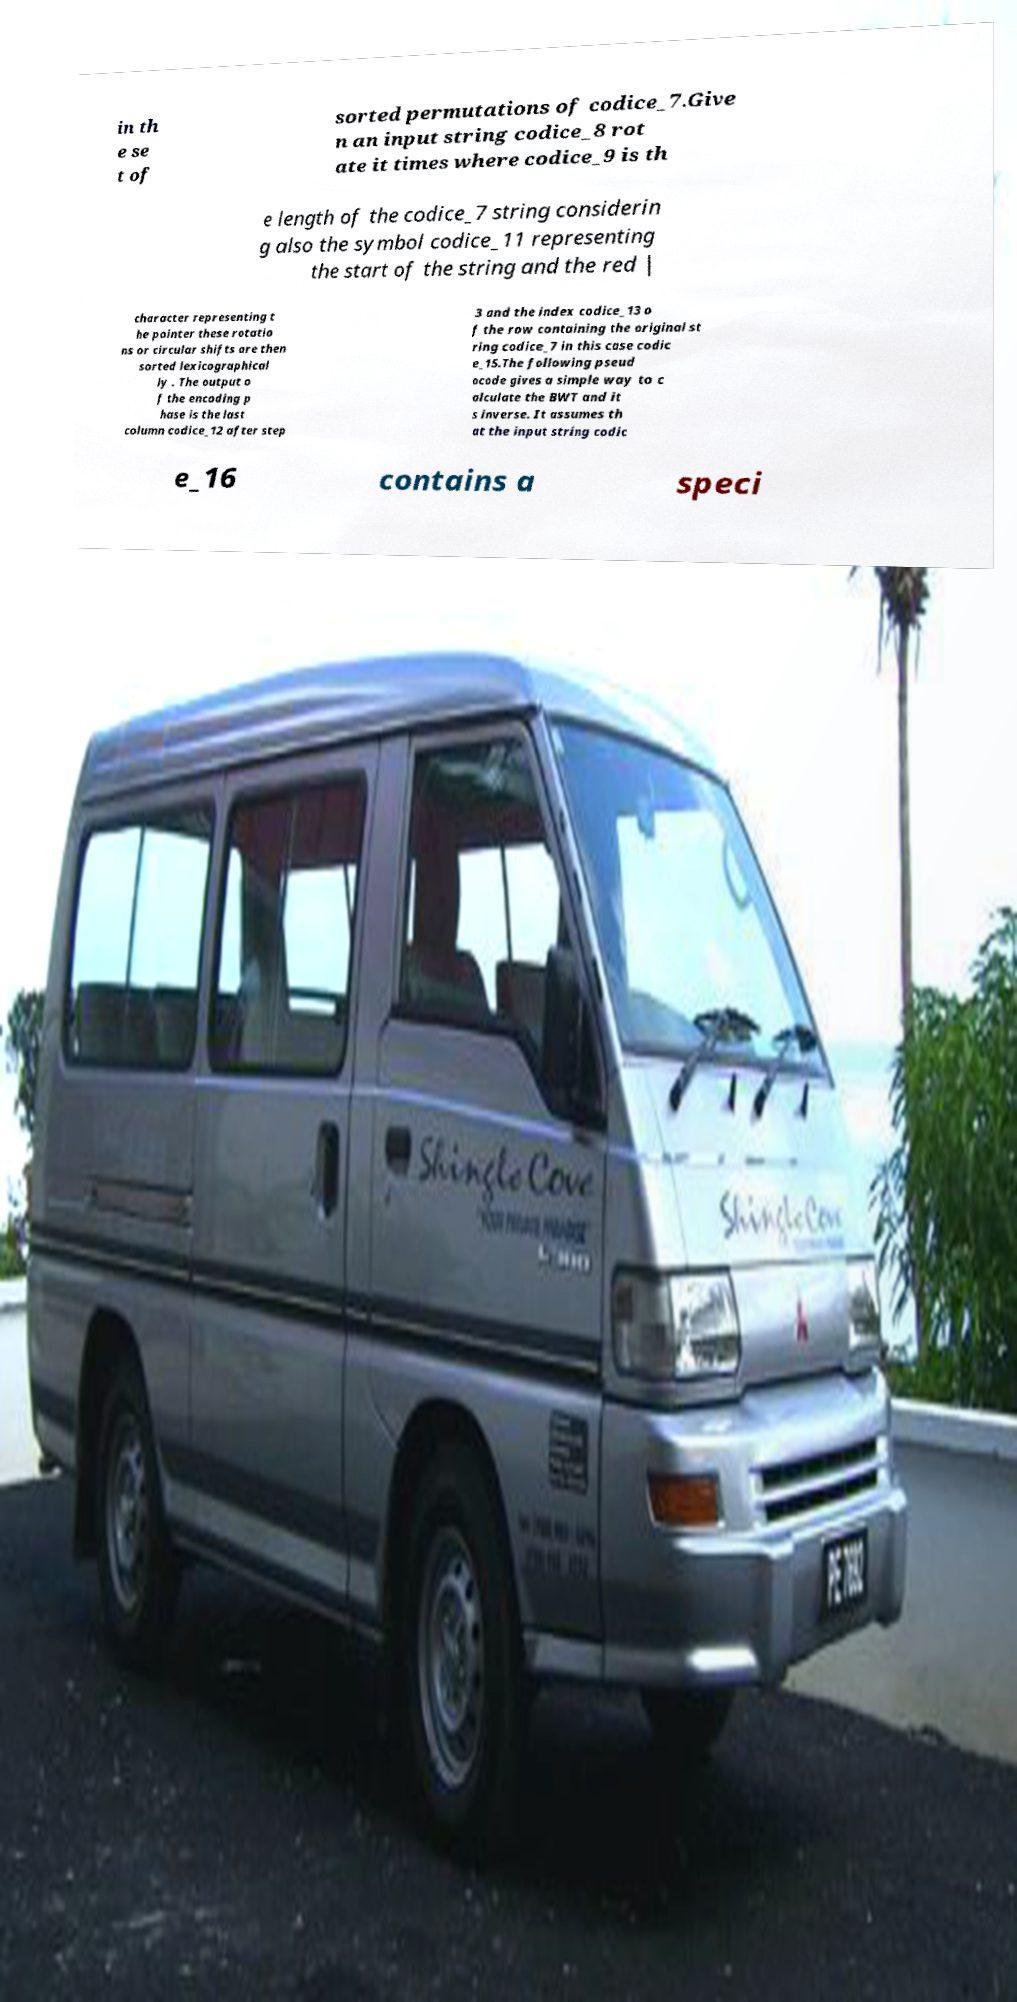There's text embedded in this image that I need extracted. Can you transcribe it verbatim? in th e se t of sorted permutations of codice_7.Give n an input string codice_8 rot ate it times where codice_9 is th e length of the codice_7 string considerin g also the symbol codice_11 representing the start of the string and the red | character representing t he pointer these rotatio ns or circular shifts are then sorted lexicographical ly . The output o f the encoding p hase is the last column codice_12 after step 3 and the index codice_13 o f the row containing the original st ring codice_7 in this case codic e_15.The following pseud ocode gives a simple way to c alculate the BWT and it s inverse. It assumes th at the input string codic e_16 contains a speci 